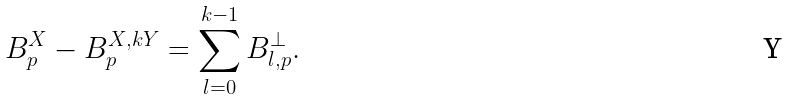<formula> <loc_0><loc_0><loc_500><loc_500>B _ { p } ^ { X } - B _ { p } ^ { X , k Y } = \sum _ { l = 0 } ^ { k - 1 } B _ { l , p } ^ { \perp } .</formula> 